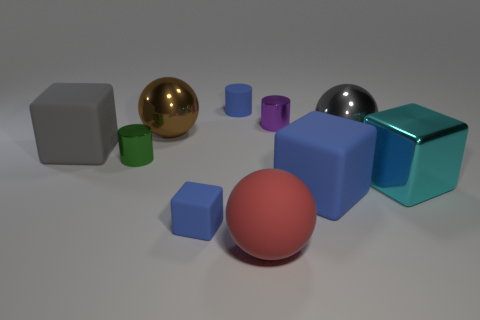Subtract all small blue cylinders. How many cylinders are left? 2 Subtract all gray balls. How many balls are left? 2 Subtract all cubes. How many objects are left? 6 Subtract all red balls. How many blue blocks are left? 2 Subtract 1 cylinders. How many cylinders are left? 2 Add 3 large gray objects. How many large gray objects are left? 5 Add 9 big cyan metallic cylinders. How many big cyan metallic cylinders exist? 9 Subtract 0 blue spheres. How many objects are left? 10 Subtract all yellow spheres. Subtract all yellow cylinders. How many spheres are left? 3 Subtract all big cyan objects. Subtract all small green shiny cylinders. How many objects are left? 8 